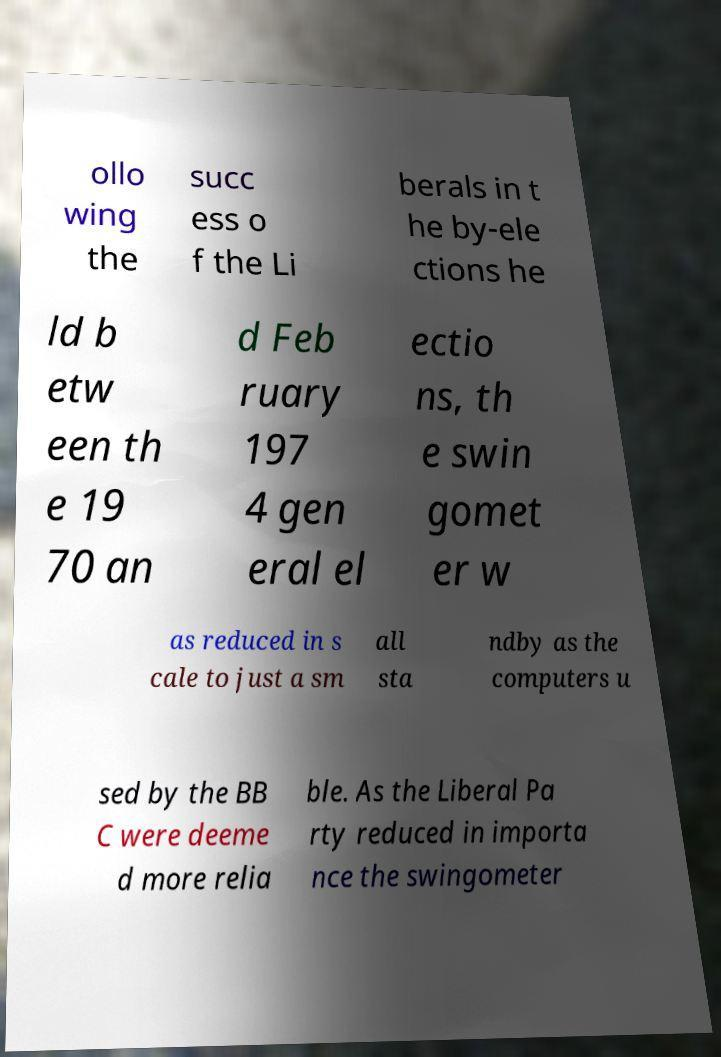What messages or text are displayed in this image? I need them in a readable, typed format. ollo wing the succ ess o f the Li berals in t he by-ele ctions he ld b etw een th e 19 70 an d Feb ruary 197 4 gen eral el ectio ns, th e swin gomet er w as reduced in s cale to just a sm all sta ndby as the computers u sed by the BB C were deeme d more relia ble. As the Liberal Pa rty reduced in importa nce the swingometer 